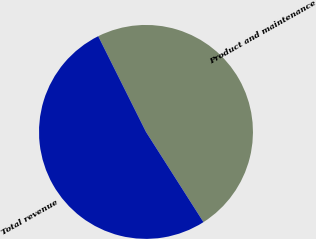<chart> <loc_0><loc_0><loc_500><loc_500><pie_chart><fcel>Product and maintenance<fcel>Total revenue<nl><fcel>48.34%<fcel>51.66%<nl></chart> 